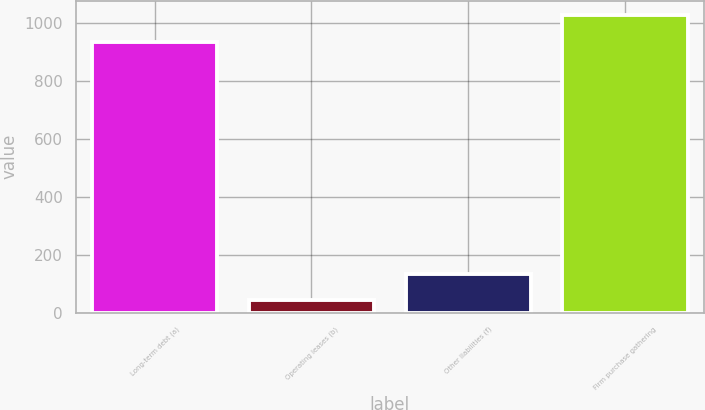Convert chart. <chart><loc_0><loc_0><loc_500><loc_500><bar_chart><fcel>Long-term debt (a)<fcel>Operating leases (b)<fcel>Other liabilities (f)<fcel>Firm purchase gathering<nl><fcel>935<fcel>44<fcel>135.1<fcel>1026.1<nl></chart> 